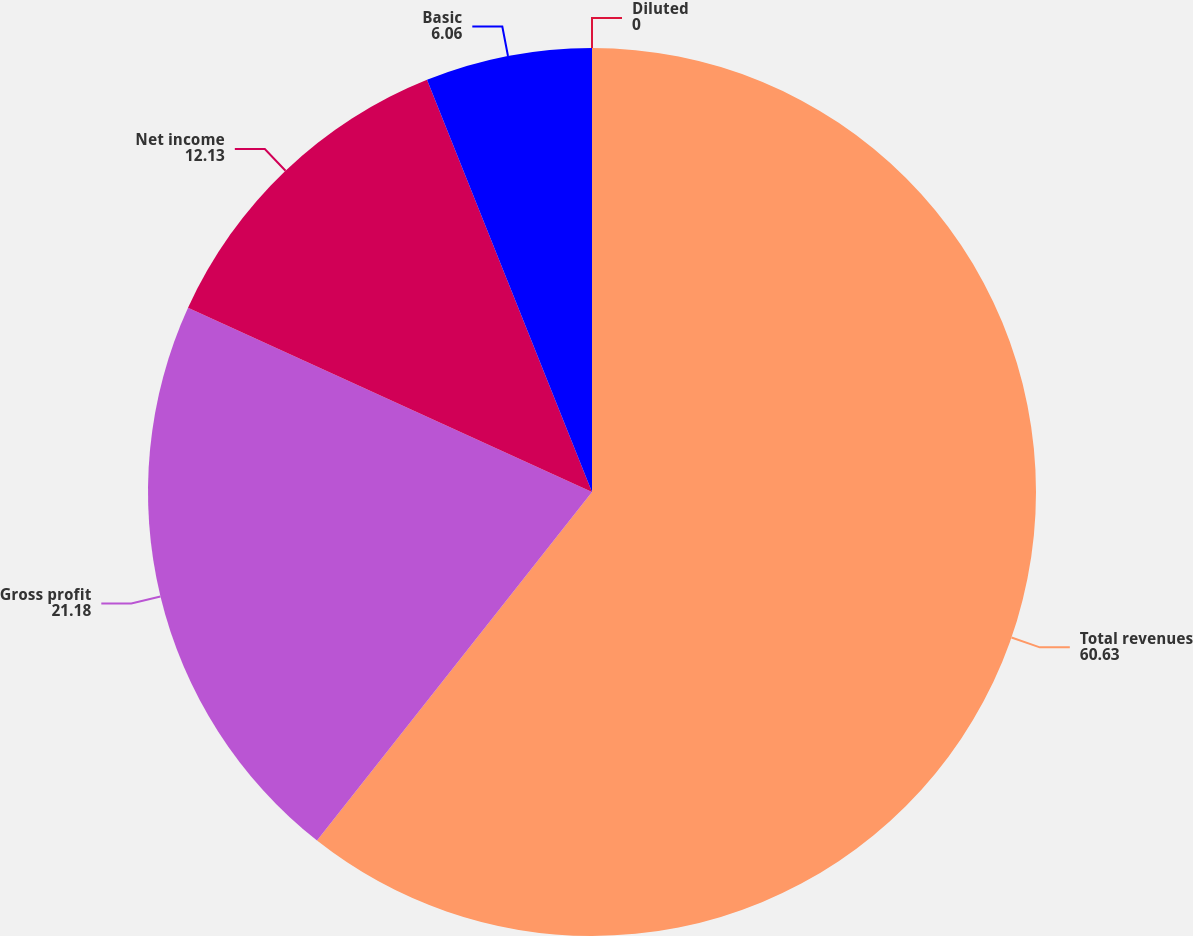Convert chart. <chart><loc_0><loc_0><loc_500><loc_500><pie_chart><fcel>Total revenues<fcel>Gross profit<fcel>Net income<fcel>Basic<fcel>Diluted<nl><fcel>60.63%<fcel>21.18%<fcel>12.13%<fcel>6.06%<fcel>0.0%<nl></chart> 